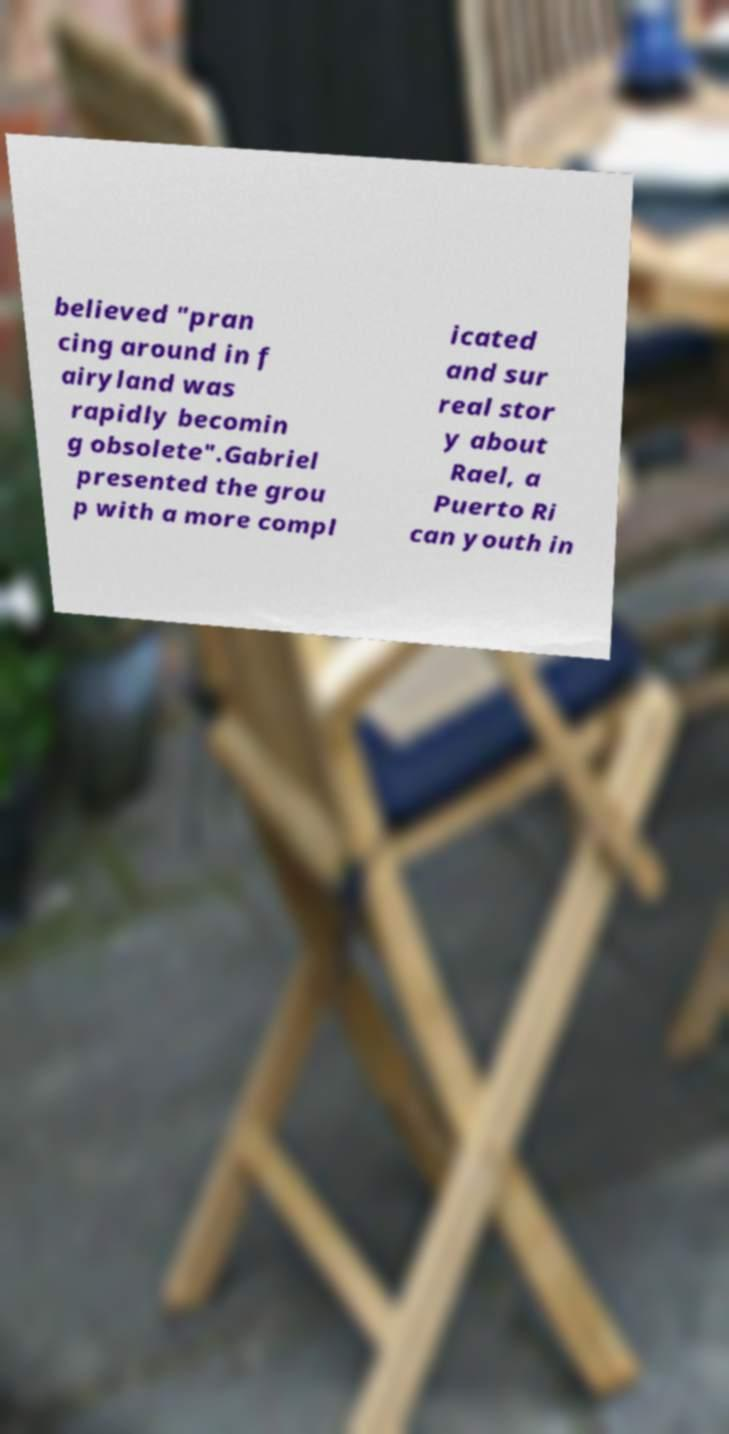Can you accurately transcribe the text from the provided image for me? believed "pran cing around in f airyland was rapidly becomin g obsolete".Gabriel presented the grou p with a more compl icated and sur real stor y about Rael, a Puerto Ri can youth in 